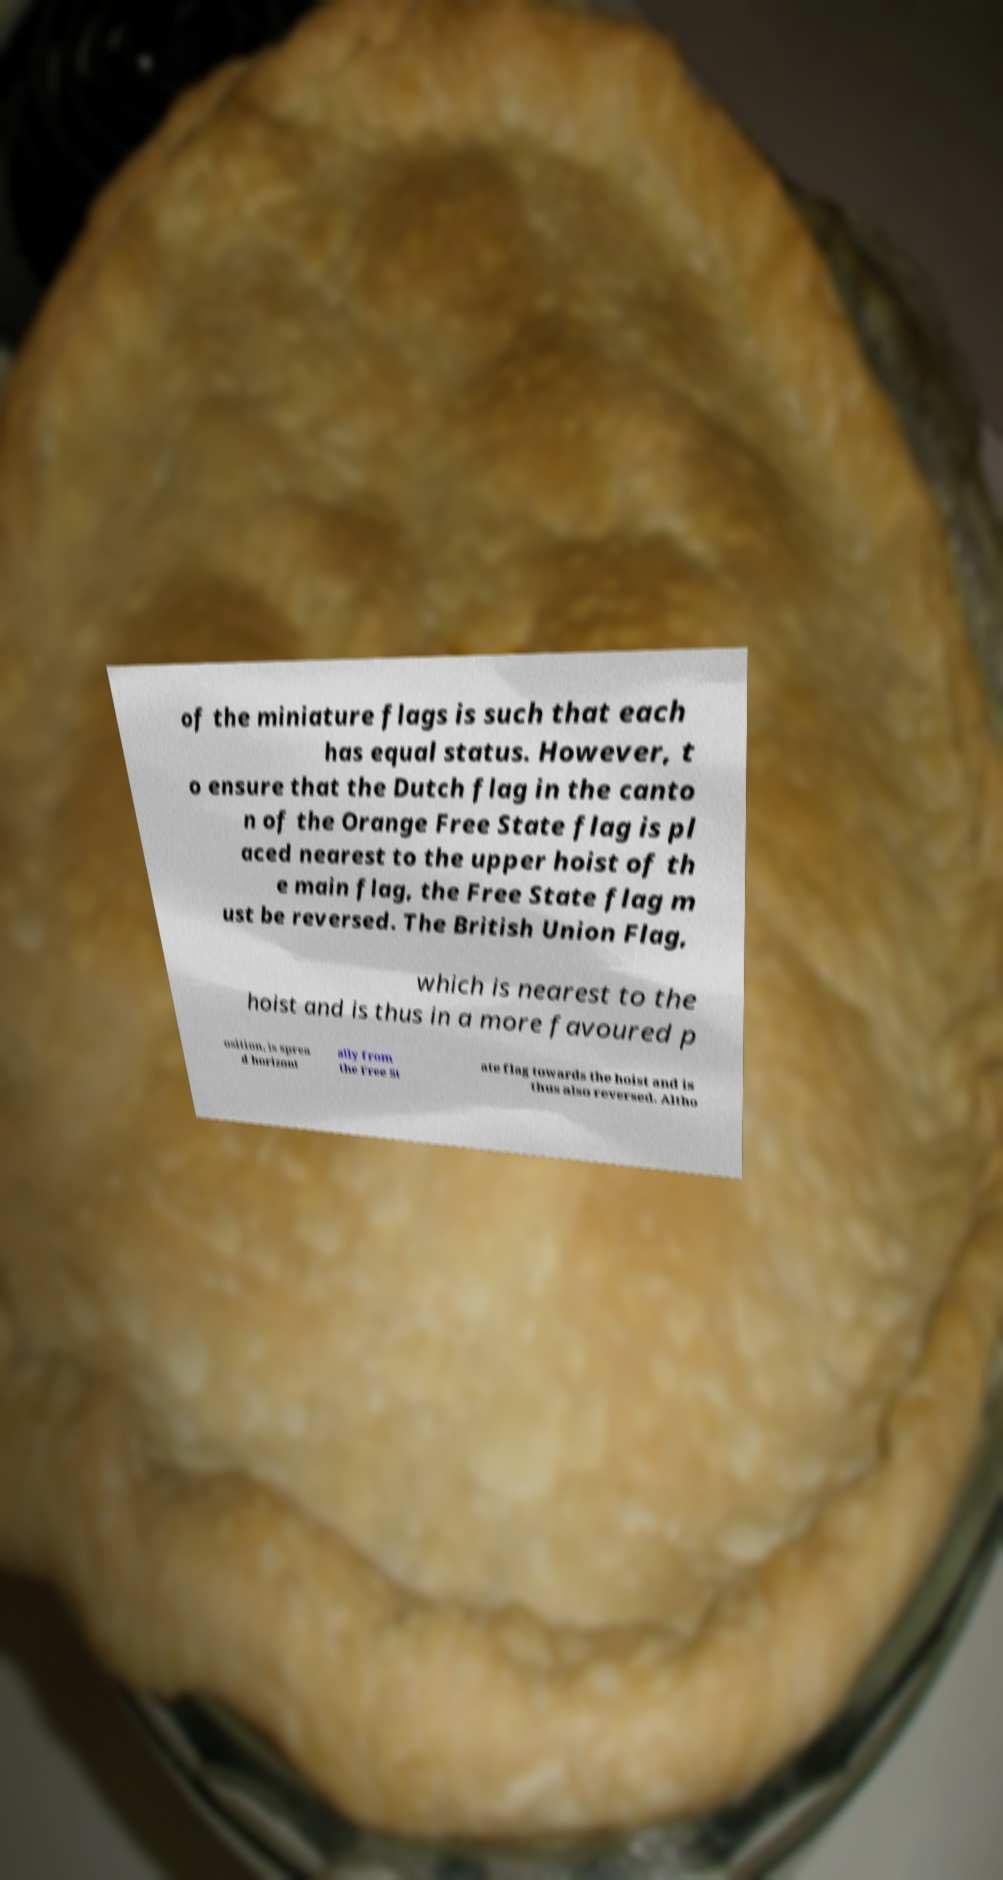There's text embedded in this image that I need extracted. Can you transcribe it verbatim? of the miniature flags is such that each has equal status. However, t o ensure that the Dutch flag in the canto n of the Orange Free State flag is pl aced nearest to the upper hoist of th e main flag, the Free State flag m ust be reversed. The British Union Flag, which is nearest to the hoist and is thus in a more favoured p osition, is sprea d horizont ally from the Free St ate flag towards the hoist and is thus also reversed. Altho 